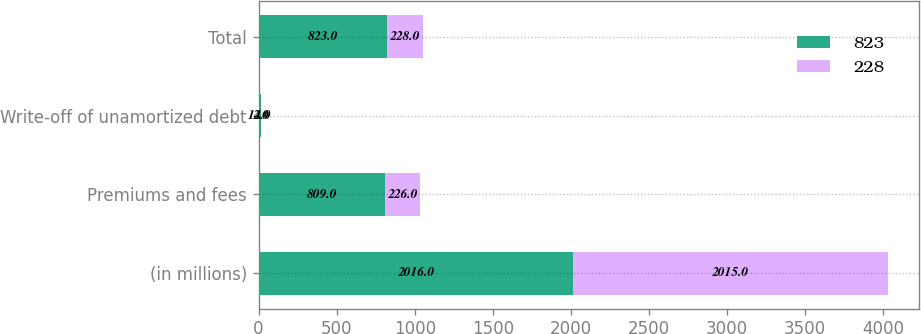Convert chart to OTSL. <chart><loc_0><loc_0><loc_500><loc_500><stacked_bar_chart><ecel><fcel>(in millions)<fcel>Premiums and fees<fcel>Write-off of unamortized debt<fcel>Total<nl><fcel>823<fcel>2016<fcel>809<fcel>14<fcel>823<nl><fcel>228<fcel>2015<fcel>226<fcel>2<fcel>228<nl></chart> 